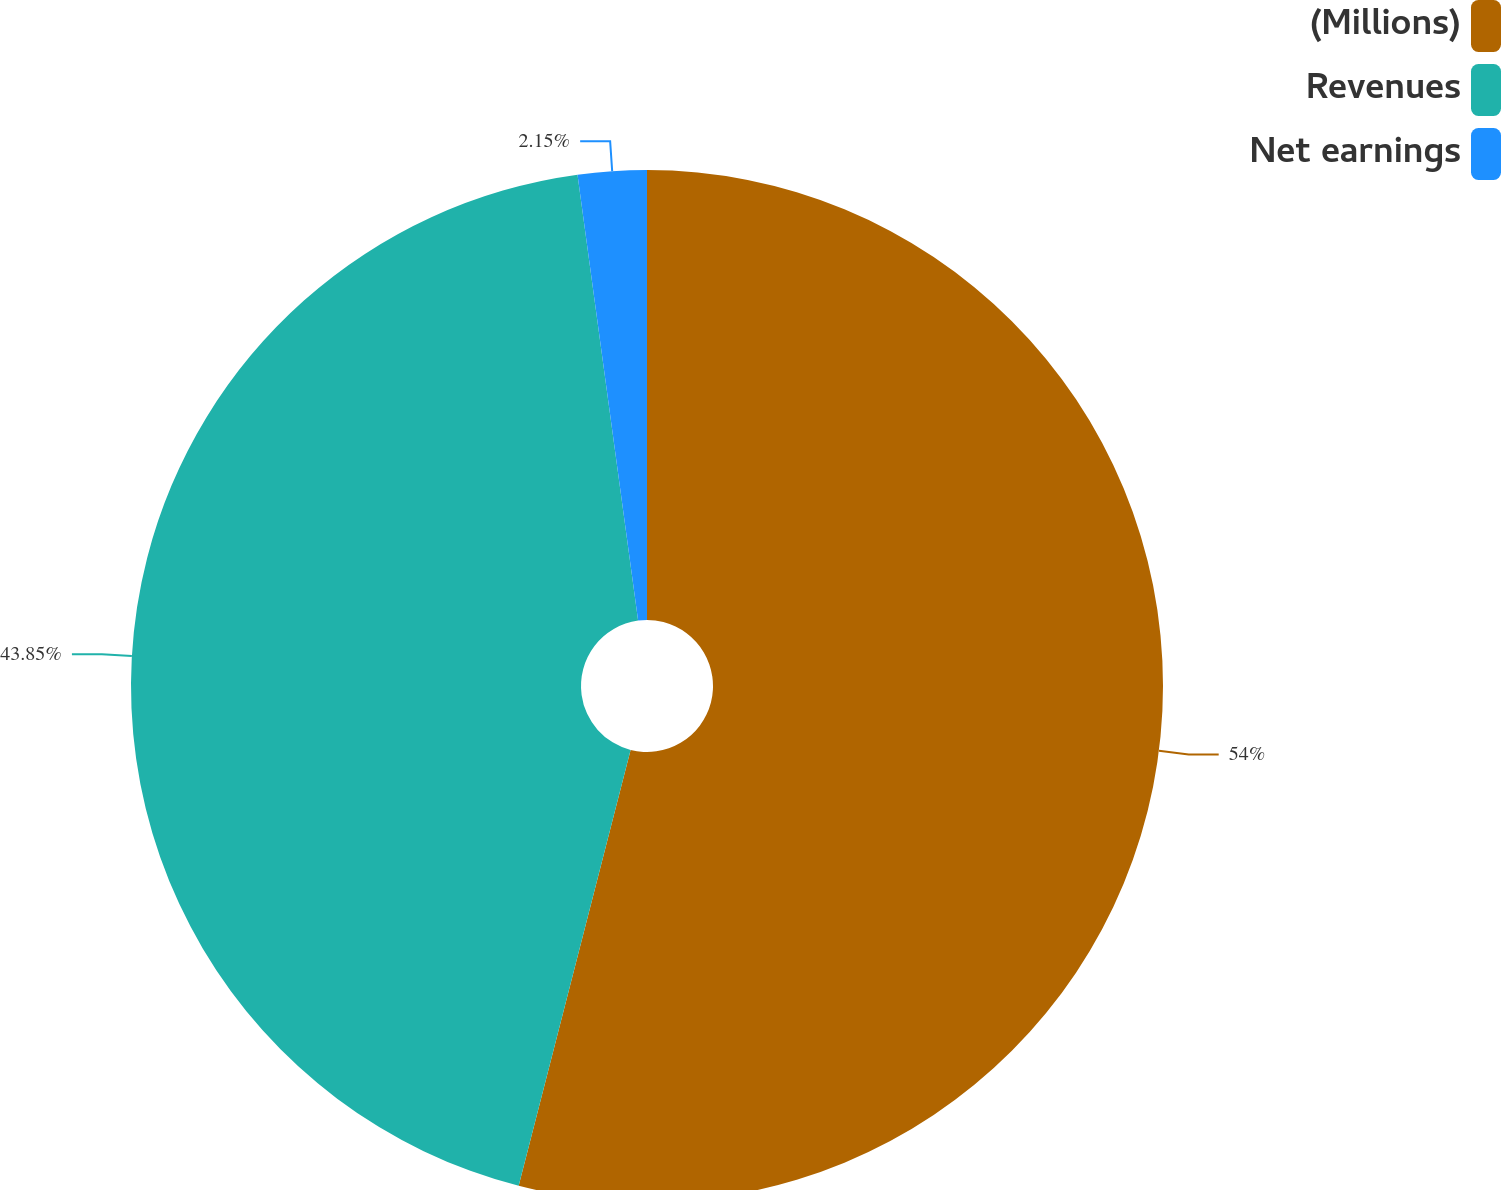<chart> <loc_0><loc_0><loc_500><loc_500><pie_chart><fcel>(Millions)<fcel>Revenues<fcel>Net earnings<nl><fcel>54.0%<fcel>43.85%<fcel>2.15%<nl></chart> 